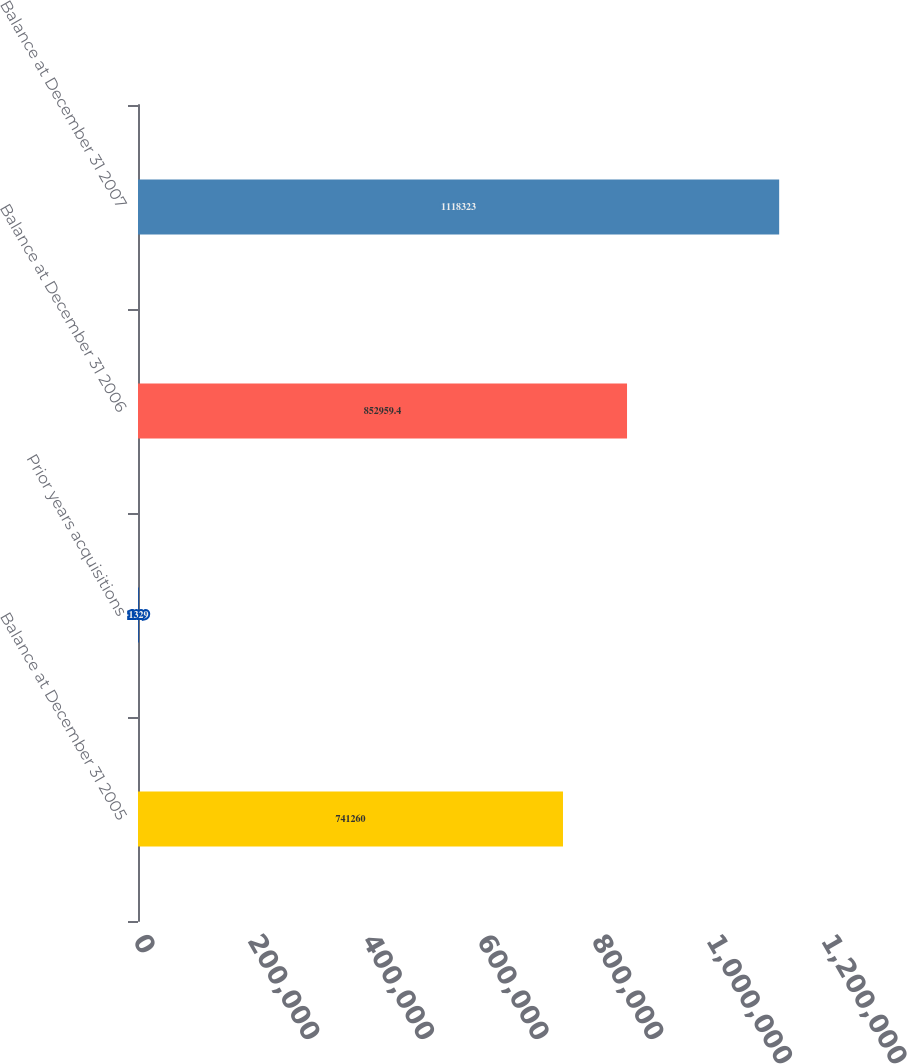Convert chart. <chart><loc_0><loc_0><loc_500><loc_500><bar_chart><fcel>Balance at December 31 2005<fcel>Prior years acquisitions<fcel>Balance at December 31 2006<fcel>Balance at December 31 2007<nl><fcel>741260<fcel>1329<fcel>852959<fcel>1.11832e+06<nl></chart> 